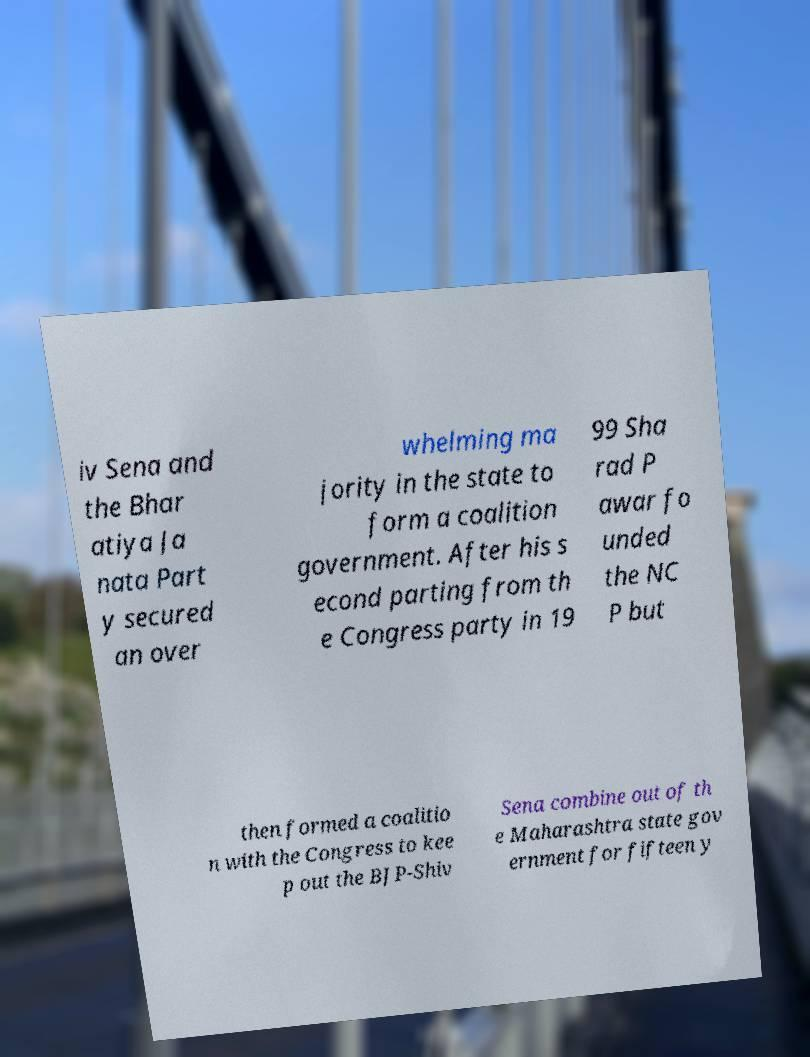I need the written content from this picture converted into text. Can you do that? iv Sena and the Bhar atiya Ja nata Part y secured an over whelming ma jority in the state to form a coalition government. After his s econd parting from th e Congress party in 19 99 Sha rad P awar fo unded the NC P but then formed a coalitio n with the Congress to kee p out the BJP-Shiv Sena combine out of th e Maharashtra state gov ernment for fifteen y 